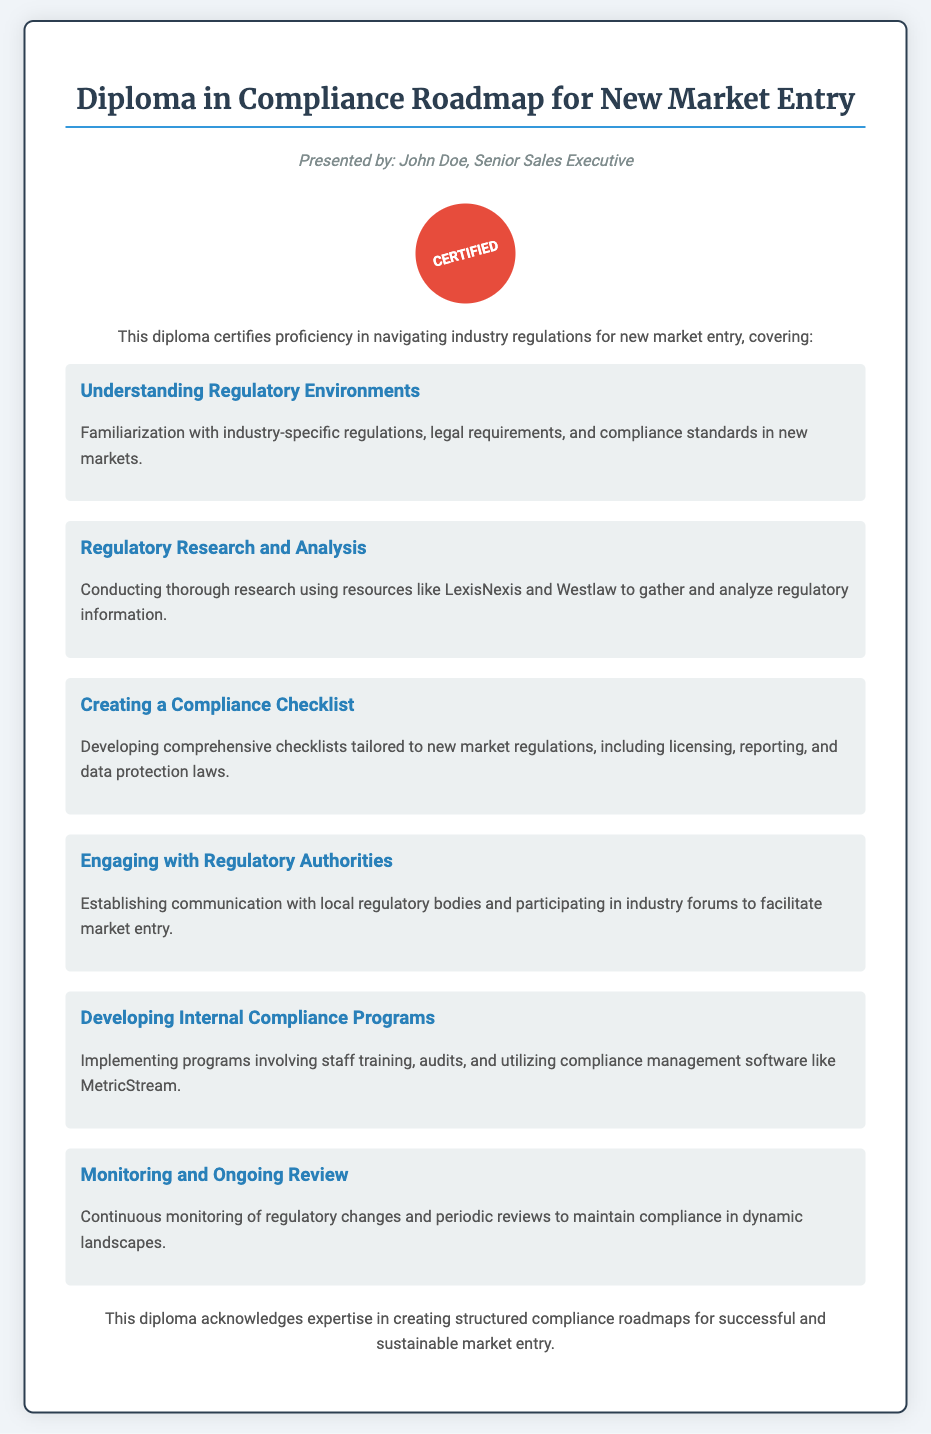What is the title of the diploma? The title of the diploma is presented at the top of the document.
Answer: Diploma in Compliance Roadmap for New Market Entry Who presented the diploma? The author's name is listed below the title as the presenter.
Answer: John Doe How many main topics are covered in the diploma? The document lists six sections that outline the topics covered.
Answer: Six What is included in the section about "Creating a Compliance Checklist"? The specific content of the section outlines what it covers in the document.
Answer: Developing comprehensive checklists tailored to new market regulations Which software is mentioned for compliance management? The document specifies a particular software within the "Developing Internal Compliance Programs" section.
Answer: MetricStream What does the seal signify? The seal appears to indicate certification within the diploma.
Answer: Certified What is emphasized in the "Monitoring and Ongoing Review" section? The document highlights a specific focus for maintaining compliance as outlined in the section.
Answer: Continuous monitoring of regulatory changes What type of communication is encouraged with local regulatory bodies? The section on "Engaging with Regulatory Authorities" suggests a specific type of interaction.
Answer: Establishing communication 